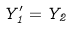Convert formula to latex. <formula><loc_0><loc_0><loc_500><loc_500>Y _ { 1 } ^ { \prime } = Y _ { 2 }</formula> 